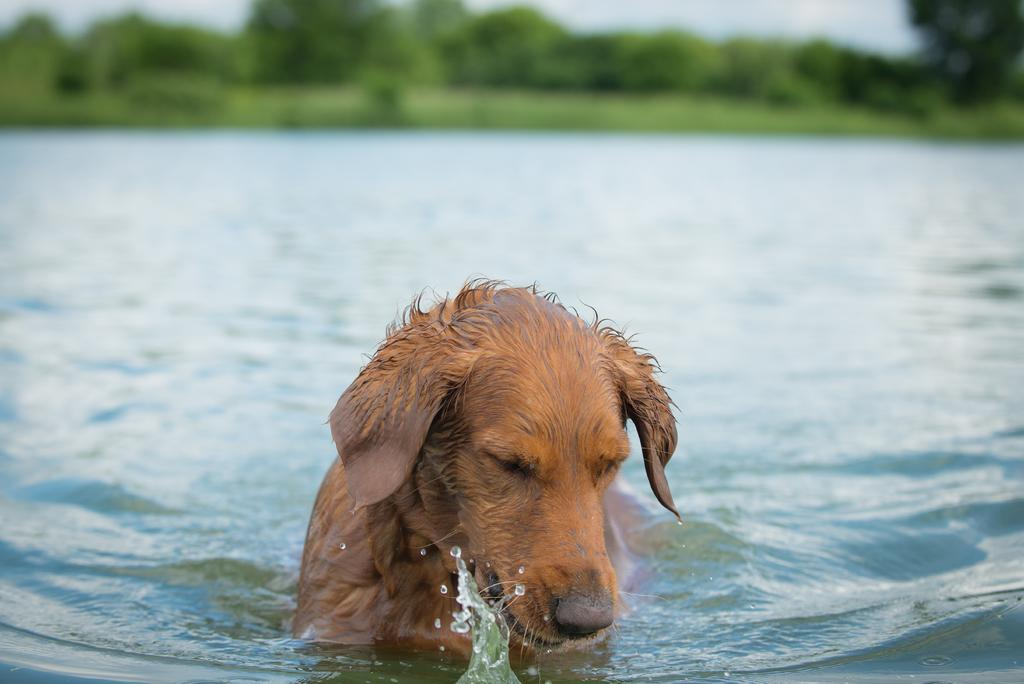What type of natural environment is depicted in the image? There are many trees and plants in the image, suggesting a natural environment. What body of water is present in the image? There is a lake in the image. What animal can be seen in the water? There is a dog in the water. What part of the sky is visible in the image? The sky is visible in the image. Where is the baby located in the image? There is no baby present in the image. What route does the dog take to swim across the lake in the image? The image does not show the dog swimming across the lake, so it is not possible to determine the route it would take. 